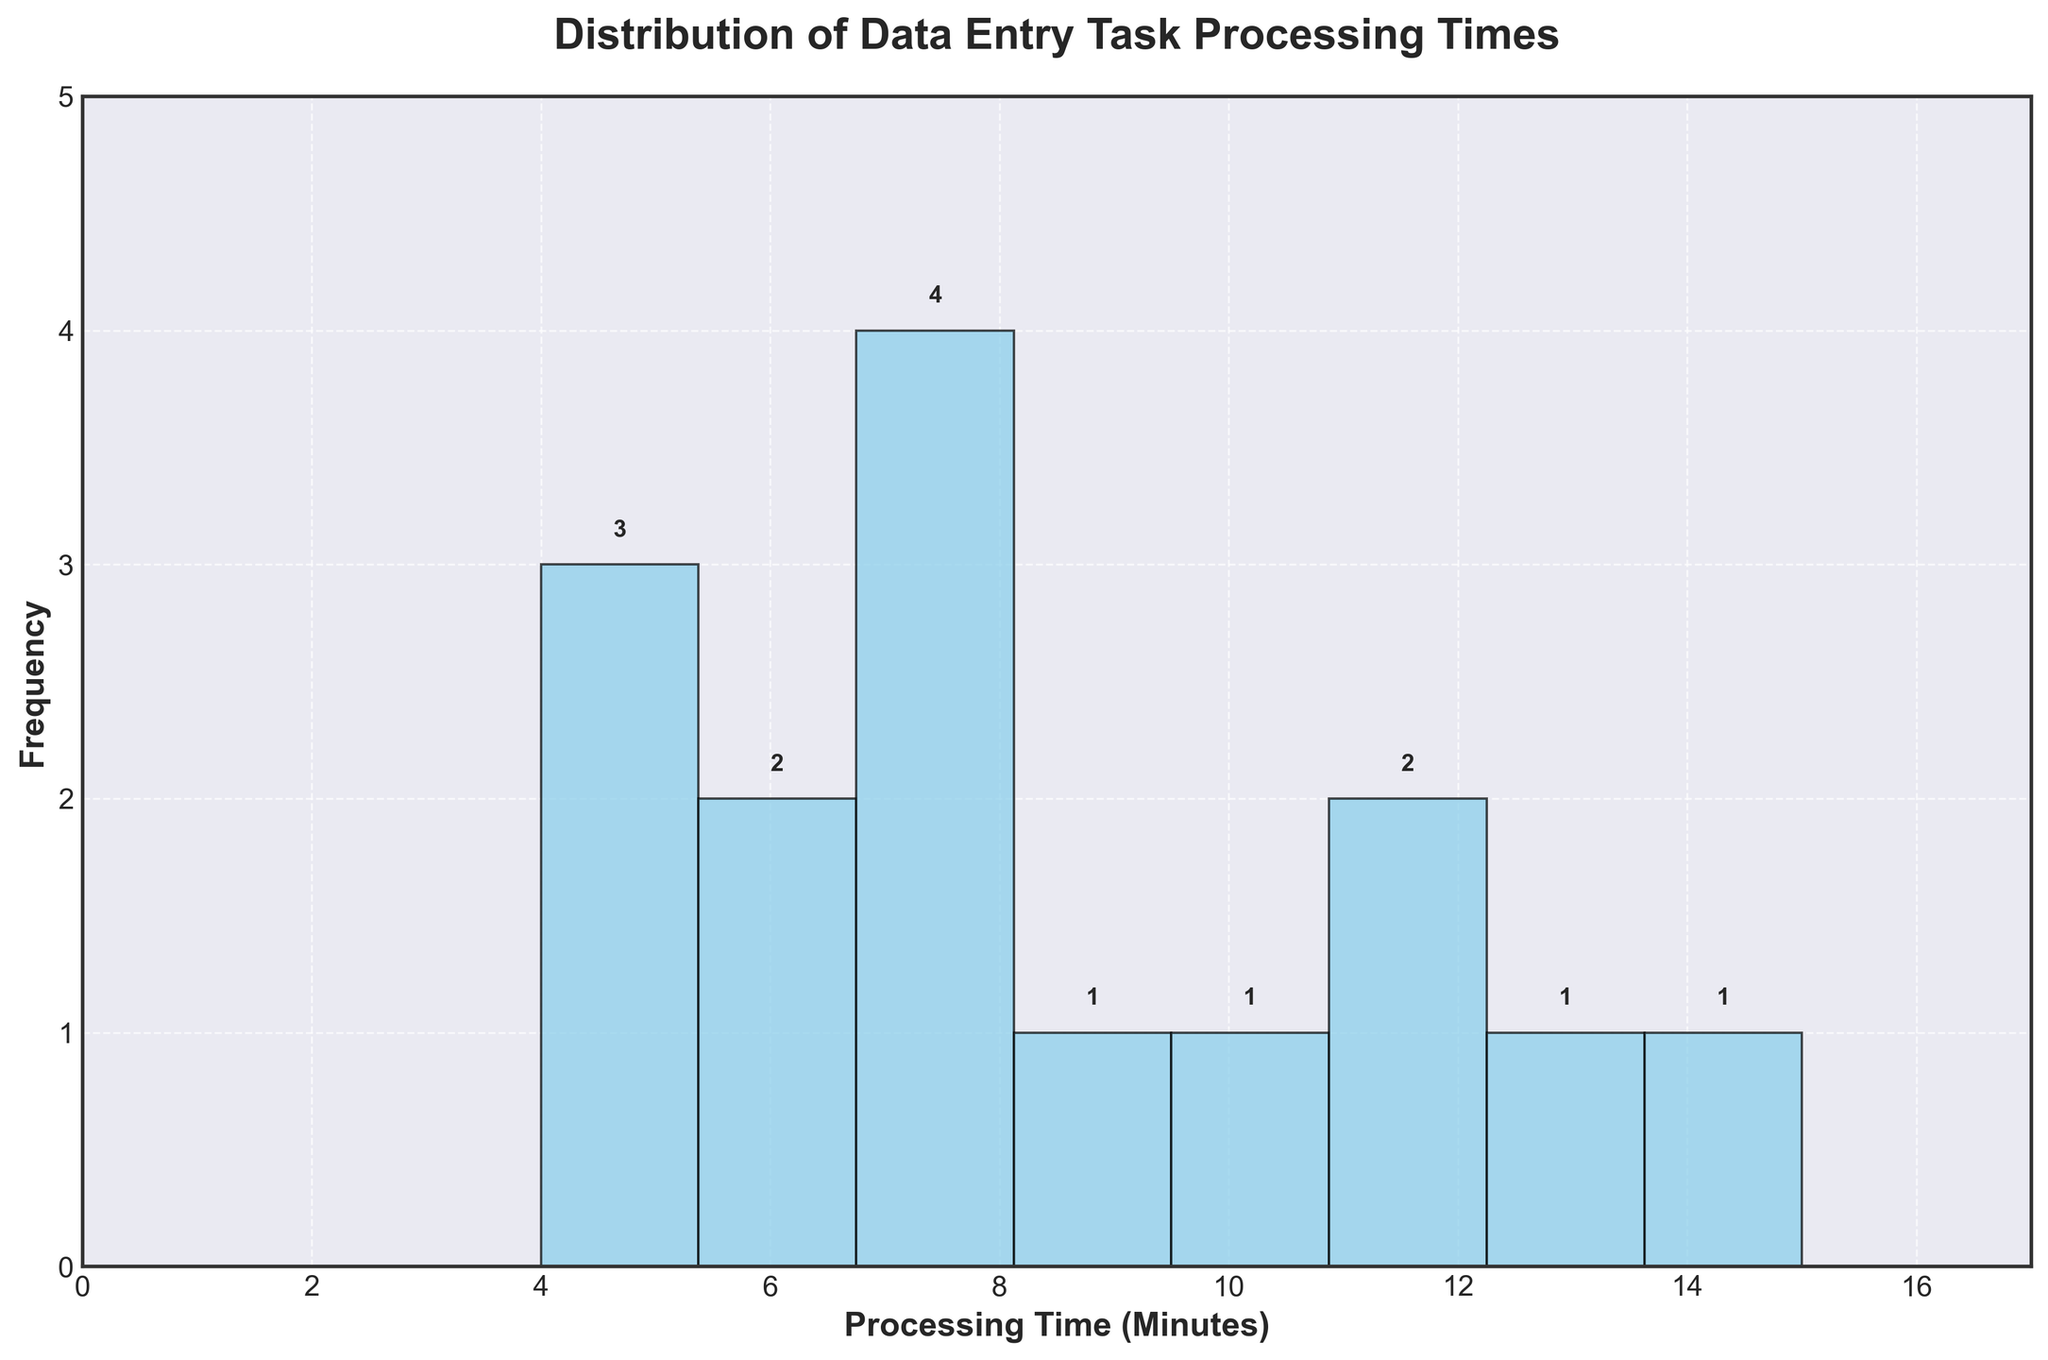What is the title of the histogram? The title of the histogram is displayed at the top of the plot. It provides a summary of the information being visualized.
Answer: Distribution of Data Entry Task Processing Times How many bins are used in the histogram? The number of bins is depicted by the number of vertical bars in the histogram. Each bin represents a range of processing times.
Answer: 8 Which range of processing times has the highest frequency? By observing the height of the bars, the bin with the maximum height indicates the highest frequency. Analyze the x-axis ranges to determine the exact range.
Answer: 5-7 minutes How many tasks fall into the 4-6 minutes range? Locate the bar within the 4-6 minute range and read the frequency value printed above this bar to determine the count of tasks.
Answer: 3 tasks What is the color of the bars in the histogram? The bars are color-coded, and this color is consistent across all bars, which can be visually confirmed.
Answer: Sky blue Which processing time range has the lowest frequency? Identify the bar with the minimum height, then check the corresponding range on the x-axis to find out which range has the fewest tasks.
Answer: 12-14 minutes How many tasks took longer than 10 minutes? Sum up the frequencies of all the bars representing processing times greater than 10 minutes by checking their heights.
Answer: 4 tasks What is the range of the x-axis (processing time)? The range of the x-axis can be identified by the minimum and maximum values labeled on the x-axis.
Answer: 0 to 15 minutes How many data entry tasks have processing times between 10 and 12 minutes? Observe the bar(s) within this range and read the frequency value printed above it to get the count of tasks in this range.
Answer: 2 tasks What is the frequency of tasks with processing times between 7 and 9 minutes? Combine the frequencies of the bars that fall within this range by checking the labels above each relevant bar.
Answer: 3 tasks 